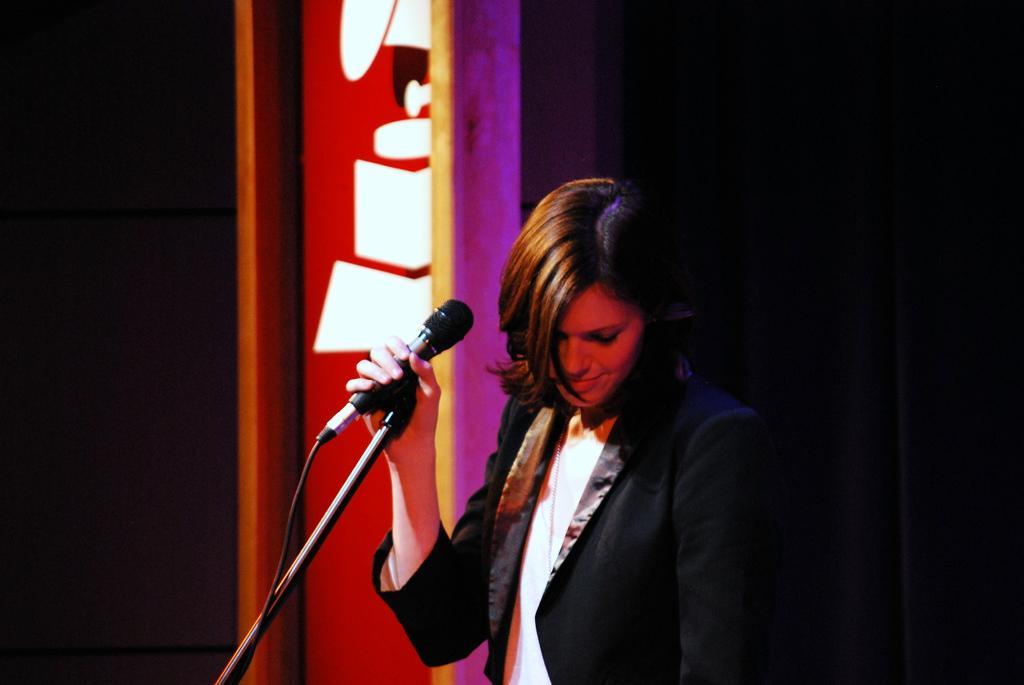How would you summarize this image in a sentence or two? women is Catching microphone in front of her 